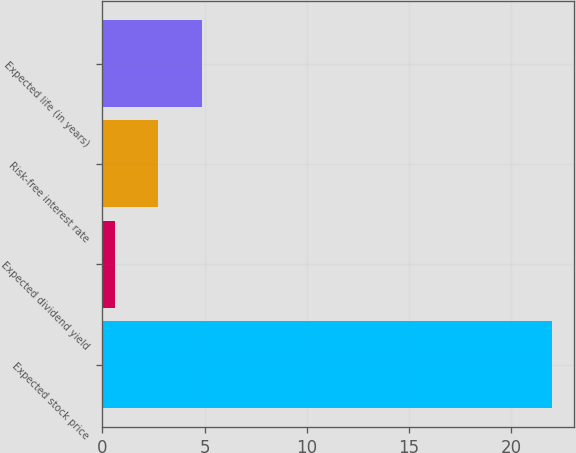<chart> <loc_0><loc_0><loc_500><loc_500><bar_chart><fcel>Expected stock price<fcel>Expected dividend yield<fcel>Risk-free interest rate<fcel>Expected life (in years)<nl><fcel>22<fcel>0.6<fcel>2.74<fcel>4.88<nl></chart> 